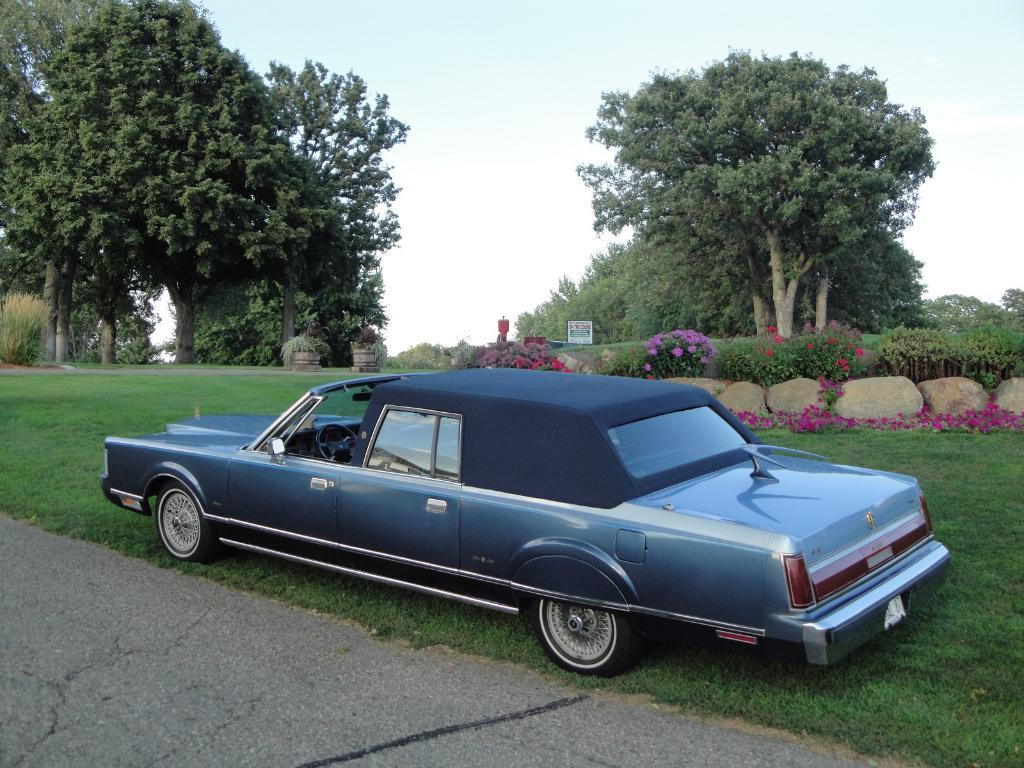What can be seen in the foreground of the picture? In the foreground of the picture, there is a pavement, grass, and a car. What is located in the center of the picture? In the center of the picture, there are trees, plants, grass, and flowers. How would you describe the sky in the picture? The sky is visible in the picture and is slightly cloudy. What type of stage can be seen in the picture? There is no stage present in the image. What point is the car trying to make in the picture? The car is not making any point in the image; it is simply a part of the scene. 